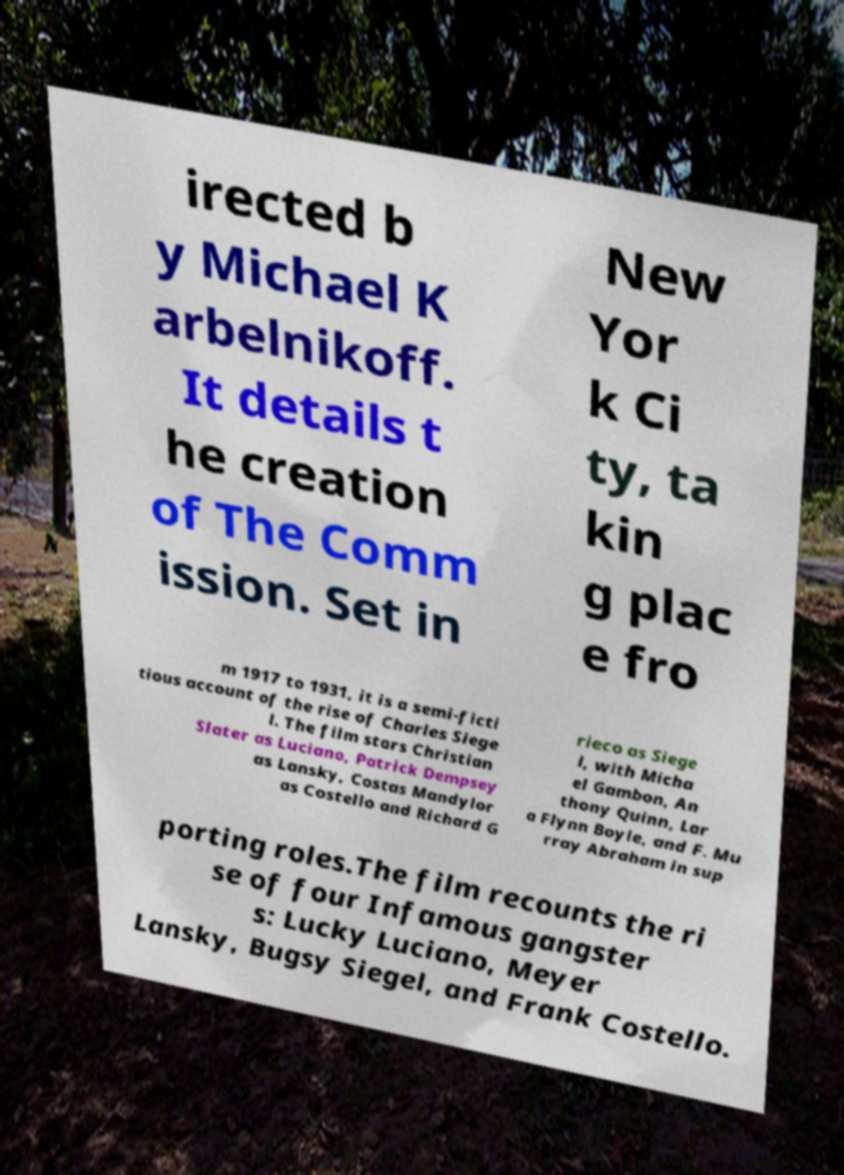Please read and relay the text visible in this image. What does it say? irected b y Michael K arbelnikoff. It details t he creation of The Comm ission. Set in New Yor k Ci ty, ta kin g plac e fro m 1917 to 1931, it is a semi-ficti tious account of the rise of Charles Siege l. The film stars Christian Slater as Luciano, Patrick Dempsey as Lansky, Costas Mandylor as Costello and Richard G rieco as Siege l, with Micha el Gambon, An thony Quinn, Lar a Flynn Boyle, and F. Mu rray Abraham in sup porting roles.The film recounts the ri se of four Infamous gangster s: Lucky Luciano, Meyer Lansky, Bugsy Siegel, and Frank Costello. 